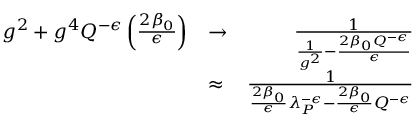Convert formula to latex. <formula><loc_0><loc_0><loc_500><loc_500>\begin{array} { r l r } { g ^ { 2 } + g ^ { 4 } Q ^ { - \epsilon } \left ( \frac { 2 \beta _ { 0 } } { \epsilon } \right ) } & { \to } & { { \frac { 1 } { { \frac { 1 } { g ^ { 2 } } } - { \frac { 2 \beta _ { 0 } Q ^ { - \epsilon } } { \epsilon } } } } } \\ & { \approx } & { { \frac { 1 } { { \frac { 2 \beta _ { 0 } } { \epsilon } } \lambda _ { P } ^ { - \epsilon } - { \frac { 2 \beta _ { 0 } } { \epsilon } } Q ^ { - \epsilon } } } } \end{array}</formula> 